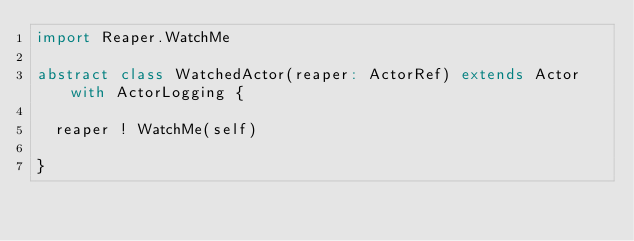Convert code to text. <code><loc_0><loc_0><loc_500><loc_500><_Scala_>import Reaper.WatchMe

abstract class WatchedActor(reaper: ActorRef) extends Actor with ActorLogging {
  
  reaper ! WatchMe(self)
  
}
</code> 